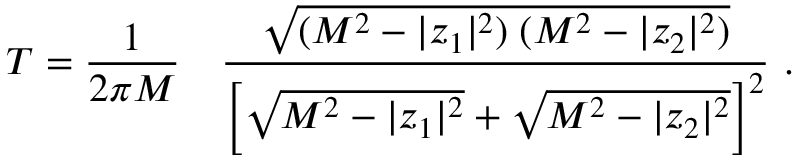<formula> <loc_0><loc_0><loc_500><loc_500>T = { \frac { 1 } { 2 \pi M } } \quad \frac { \sqrt { ( M ^ { 2 } - | z _ { 1 } | ^ { 2 } ) \, ( M ^ { 2 } - | z _ { 2 } | ^ { 2 } ) } } { \left [ \sqrt { M ^ { 2 } - | z _ { 1 } | ^ { 2 } } + \sqrt { M ^ { 2 } - | z _ { 2 } | ^ { 2 } } \right ] ^ { 2 } } \ .</formula> 